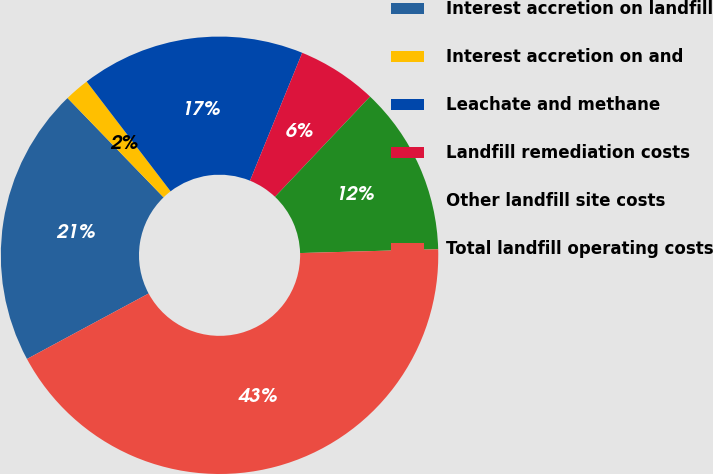Convert chart. <chart><loc_0><loc_0><loc_500><loc_500><pie_chart><fcel>Interest accretion on landfill<fcel>Interest accretion on and<fcel>Leachate and methane<fcel>Landfill remediation costs<fcel>Other landfill site costs<fcel>Total landfill operating costs<nl><fcel>20.63%<fcel>1.84%<fcel>16.56%<fcel>5.91%<fcel>12.48%<fcel>42.58%<nl></chart> 